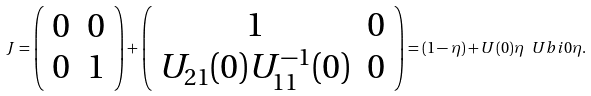<formula> <loc_0><loc_0><loc_500><loc_500>J = \left ( \begin{array} { c c } 0 & 0 \\ 0 & 1 \end{array} \right ) + \left ( \begin{array} { c c } 1 & 0 \\ U _ { 2 1 } ( 0 ) U _ { 1 1 } ^ { - 1 } ( 0 ) & 0 \end{array} \right ) = ( 1 - \eta ) + U ( 0 ) \eta \ U b i { 0 } \eta .</formula> 